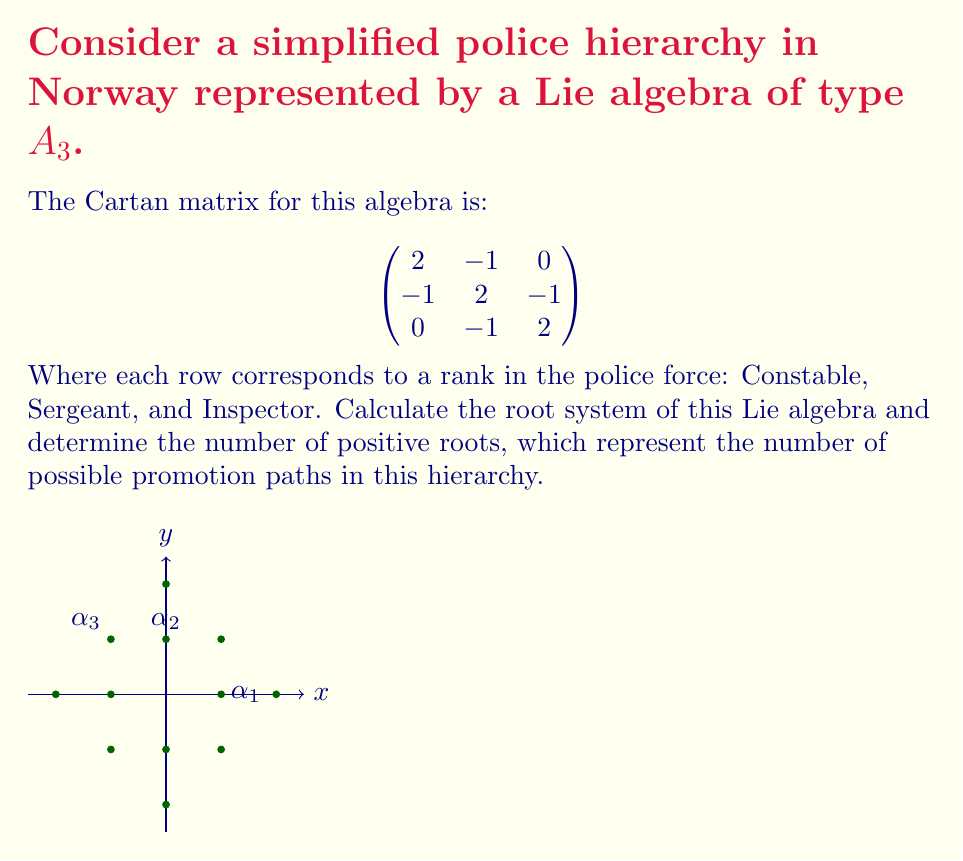Can you answer this question? To calculate the root system and determine the number of positive roots, we'll follow these steps:

1) First, we need to find the simple roots. For $A_3$, there are 3 simple roots: $\alpha_1$, $\alpha_2$, and $\alpha_3$.

2) The positive roots are all linear combinations of simple roots with non-negative integer coefficients. For $A_3$, they are:

   $\alpha_1$
   $\alpha_2$
   $\alpha_3$
   $\alpha_1 + \alpha_2$
   $\alpha_2 + \alpha_3$
   $\alpha_1 + \alpha_2 + \alpha_3$

3) The negative roots are the negatives of these positive roots.

4) To count the number of positive roots:
   - 3 simple roots
   - 2 roots that are sums of two adjacent simple roots
   - 1 root that is the sum of all three simple roots

   Total: 3 + 2 + 1 = 6 positive roots

5) The complete root system includes both positive and negative roots, so there are 12 roots in total (6 positive + 6 negative).

In the context of the police hierarchy:
- Simple roots ($\alpha_1$, $\alpha_2$, $\alpha_3$) represent direct promotions between adjacent ranks.
- Compound roots (e.g., $\alpha_1 + \alpha_2$) represent indirect promotion paths skipping intermediate ranks.
- The highest root ($\alpha_1 + \alpha_2 + \alpha_3$) represents the path from the lowest to the highest rank.

The number of positive roots (6) indicates the total number of possible promotion paths in this simplified hierarchy.
Answer: 6 positive roots 